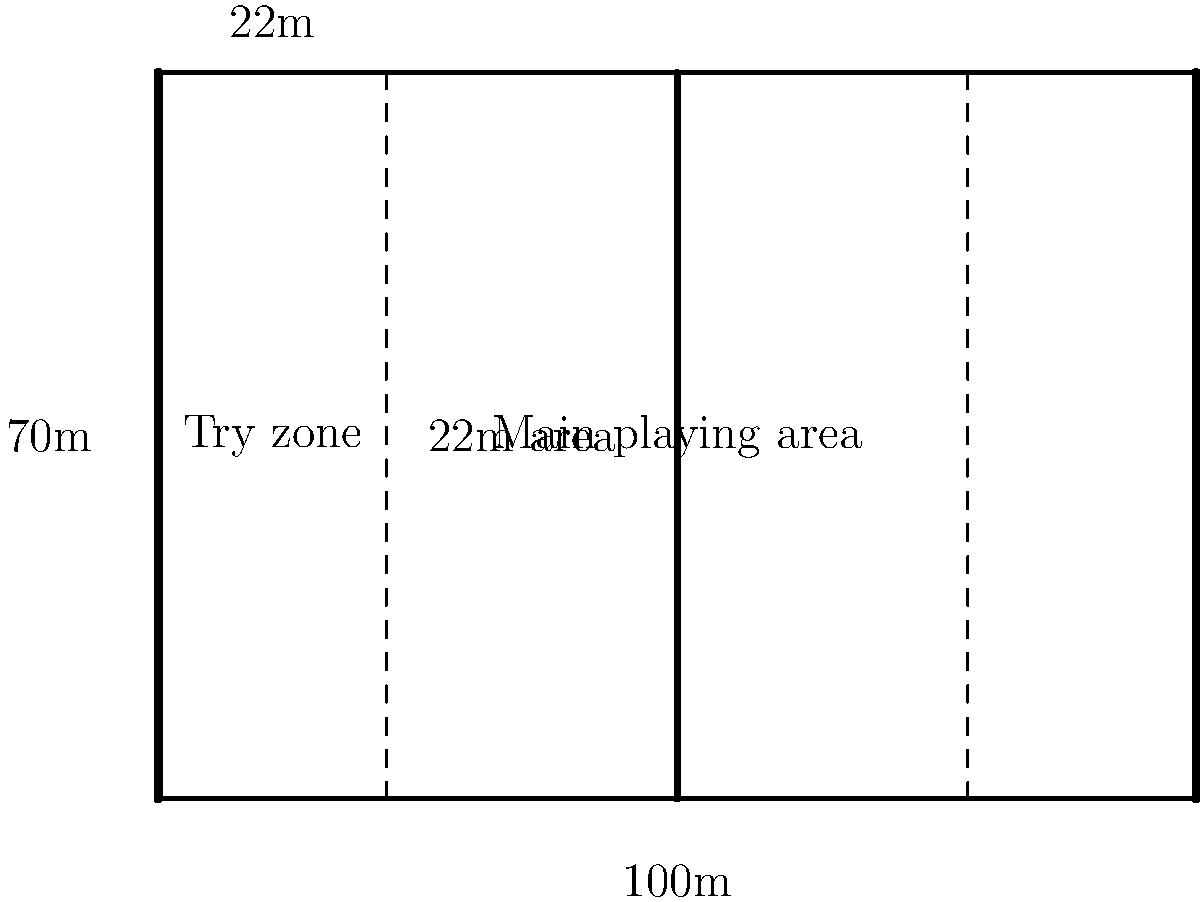As a rugby player, you need to understand the field dimensions. Based on the schematic drawing of a rugby field, what is the total distance between the two try lines? To find the total distance between the two try lines, we need to analyze the schematic drawing of the rugby field:

1. The rugby field is represented by a rectangle.
2. The total length of the field is labeled as 100m at the bottom of the diagram.
3. The try lines are shown as thick vertical lines at both ends of the field.
4. The 22-meter lines are represented by dashed lines on each side of the field.
5. The space between the try line and the 22-meter line on each side is labeled as 22m.

To calculate the distance between the try lines:
1. Total field length = 100m
2. Distance from try line to 22-meter line on each side = 22m
3. Total distance of both 22-meter areas = 22m + 22m = 44m
4. Distance between try lines = Total field length - Total 22-meter areas
5. Distance between try lines = 100m - 44m = 56m

Therefore, the total distance between the two try lines is 56 meters.
Answer: 56 meters 